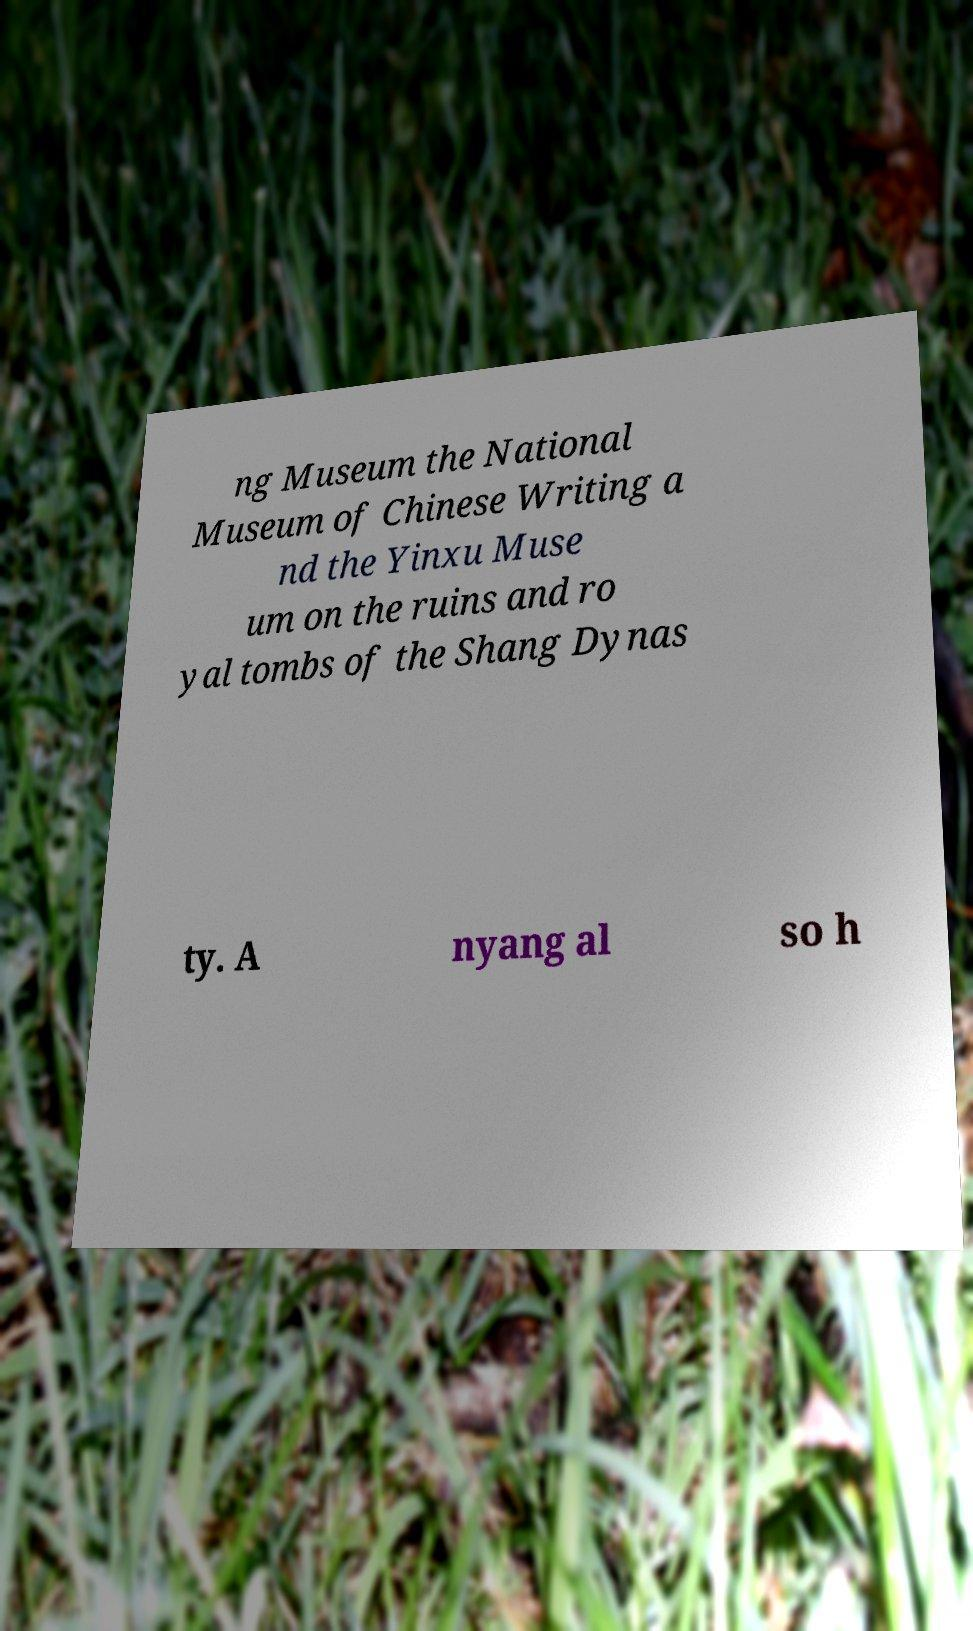Can you accurately transcribe the text from the provided image for me? ng Museum the National Museum of Chinese Writing a nd the Yinxu Muse um on the ruins and ro yal tombs of the Shang Dynas ty. A nyang al so h 